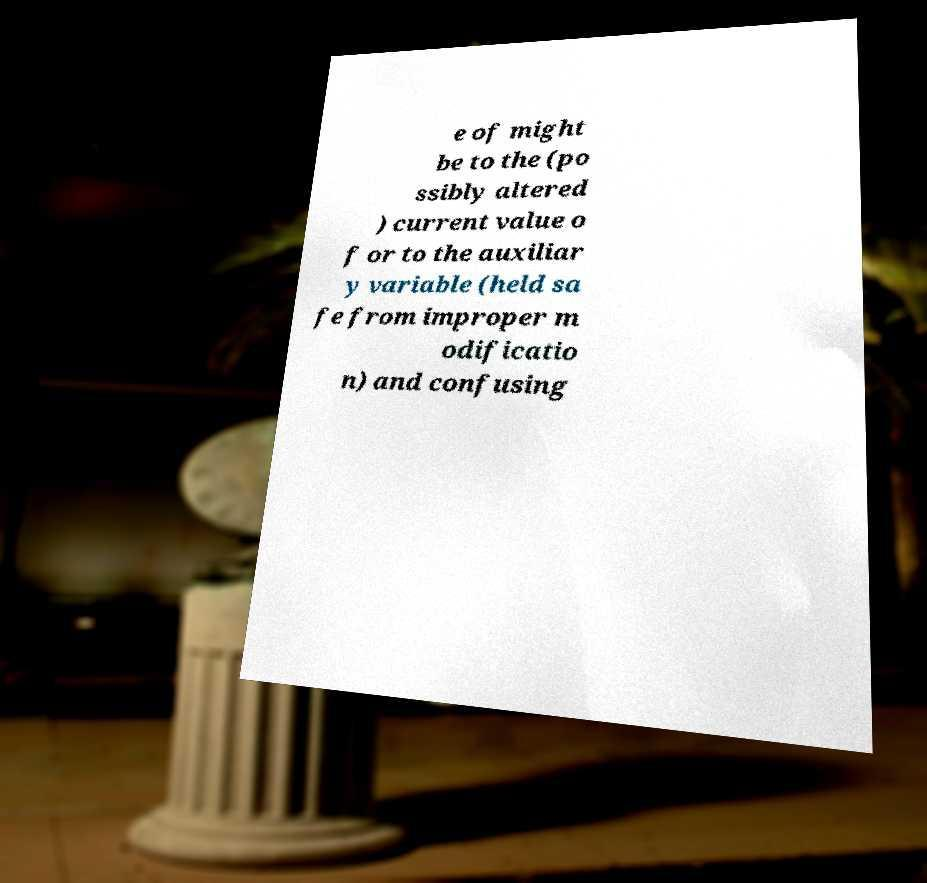Can you accurately transcribe the text from the provided image for me? e of might be to the (po ssibly altered ) current value o f or to the auxiliar y variable (held sa fe from improper m odificatio n) and confusing 